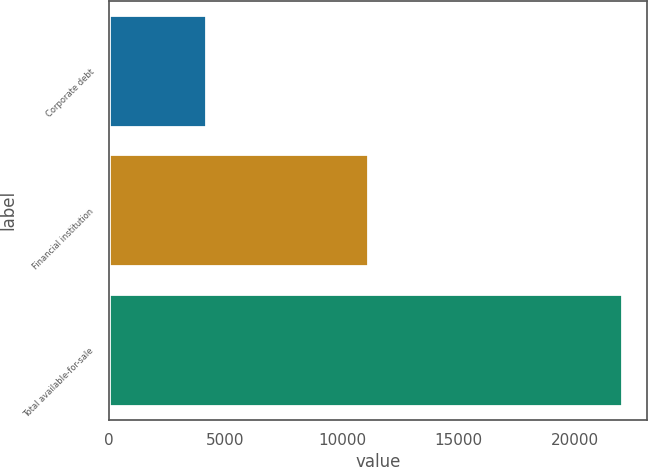<chart> <loc_0><loc_0><loc_500><loc_500><bar_chart><fcel>Corporate debt<fcel>Financial institution<fcel>Total available-for-sale<nl><fcel>4157<fcel>11139<fcel>22007<nl></chart> 